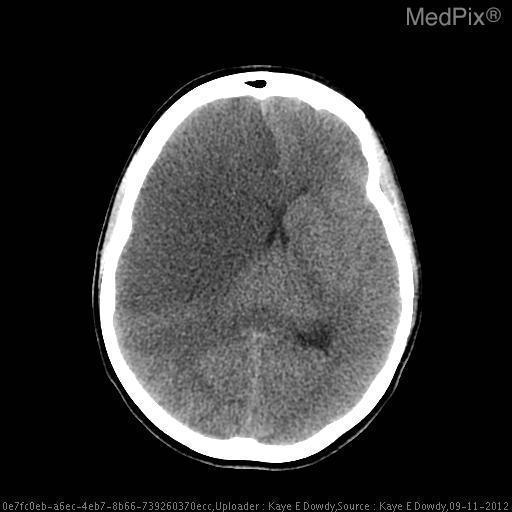What is the radiological description of the color of the edema?
Quick response, please. Hypodense. Are the lateral ventricles compressed?
Short answer required. Yes. What is the hypodensity in the posterior left?
Short answer required. The posterior horn of the left lateral ventricle. 